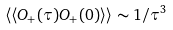<formula> <loc_0><loc_0><loc_500><loc_500>\langle \langle O _ { + } ( \tau ) O _ { + } ( 0 ) \rangle \rangle \sim 1 / \tau ^ { 3 }</formula> 